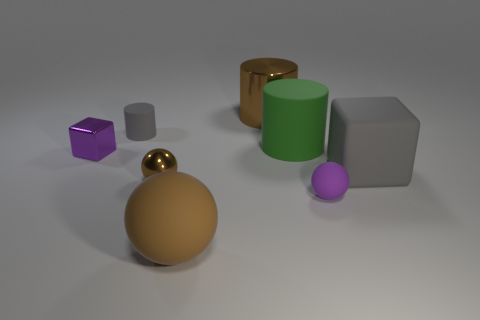Add 1 gray cylinders. How many objects exist? 9 Subtract all cubes. How many objects are left? 6 Subtract 0 yellow blocks. How many objects are left? 8 Subtract all large blocks. Subtract all big shiny cylinders. How many objects are left? 6 Add 7 big gray things. How many big gray things are left? 8 Add 8 matte cylinders. How many matte cylinders exist? 10 